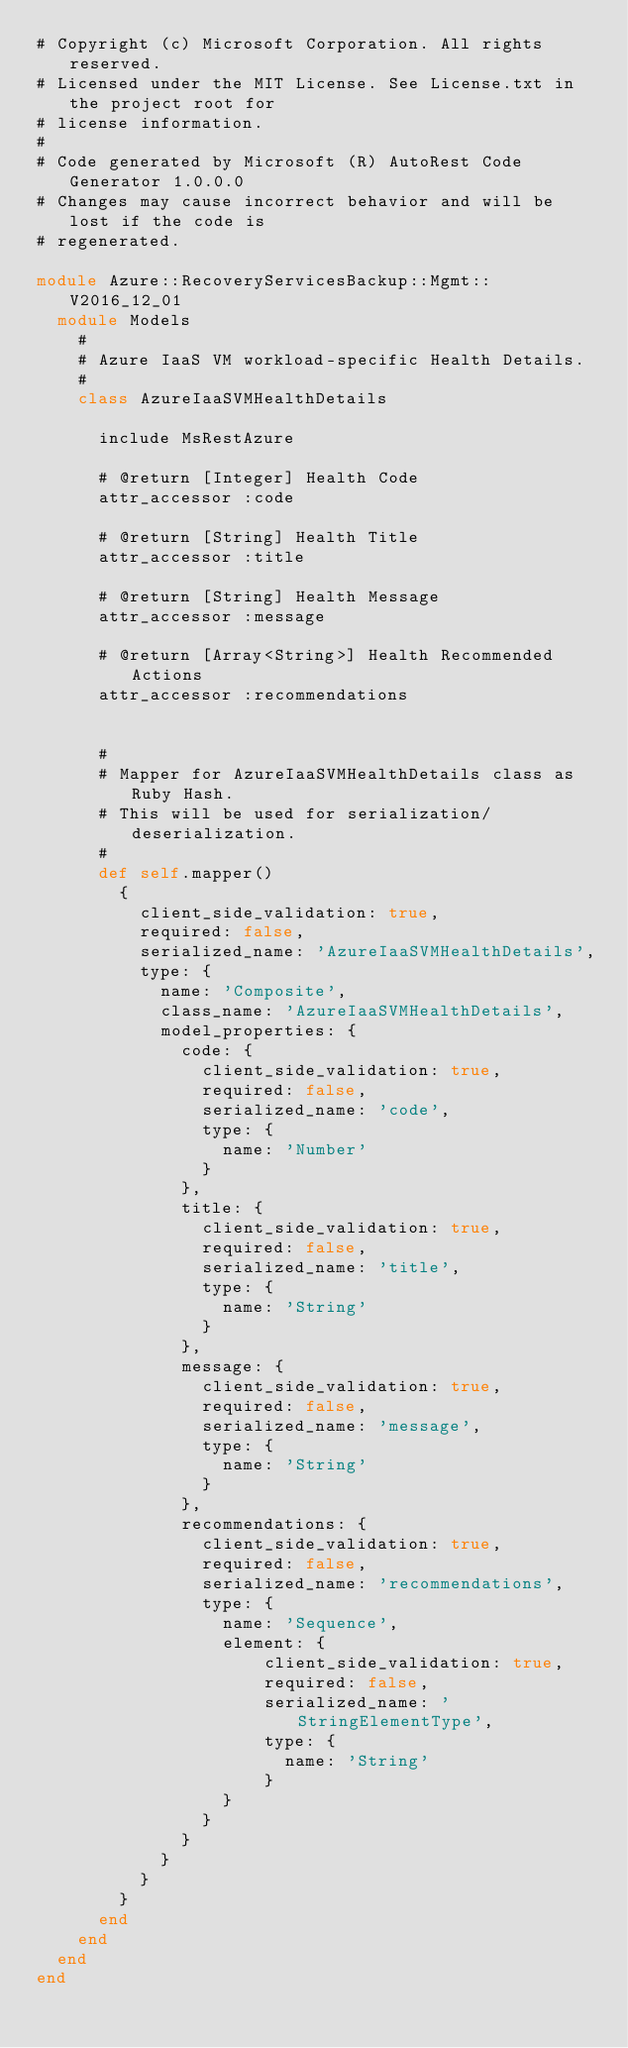<code> <loc_0><loc_0><loc_500><loc_500><_Ruby_># Copyright (c) Microsoft Corporation. All rights reserved.
# Licensed under the MIT License. See License.txt in the project root for
# license information.
#
# Code generated by Microsoft (R) AutoRest Code Generator 1.0.0.0
# Changes may cause incorrect behavior and will be lost if the code is
# regenerated.

module Azure::RecoveryServicesBackup::Mgmt::V2016_12_01
  module Models
    #
    # Azure IaaS VM workload-specific Health Details.
    #
    class AzureIaaSVMHealthDetails

      include MsRestAzure

      # @return [Integer] Health Code
      attr_accessor :code

      # @return [String] Health Title
      attr_accessor :title

      # @return [String] Health Message
      attr_accessor :message

      # @return [Array<String>] Health Recommended Actions
      attr_accessor :recommendations


      #
      # Mapper for AzureIaaSVMHealthDetails class as Ruby Hash.
      # This will be used for serialization/deserialization.
      #
      def self.mapper()
        {
          client_side_validation: true,
          required: false,
          serialized_name: 'AzureIaaSVMHealthDetails',
          type: {
            name: 'Composite',
            class_name: 'AzureIaaSVMHealthDetails',
            model_properties: {
              code: {
                client_side_validation: true,
                required: false,
                serialized_name: 'code',
                type: {
                  name: 'Number'
                }
              },
              title: {
                client_side_validation: true,
                required: false,
                serialized_name: 'title',
                type: {
                  name: 'String'
                }
              },
              message: {
                client_side_validation: true,
                required: false,
                serialized_name: 'message',
                type: {
                  name: 'String'
                }
              },
              recommendations: {
                client_side_validation: true,
                required: false,
                serialized_name: 'recommendations',
                type: {
                  name: 'Sequence',
                  element: {
                      client_side_validation: true,
                      required: false,
                      serialized_name: 'StringElementType',
                      type: {
                        name: 'String'
                      }
                  }
                }
              }
            }
          }
        }
      end
    end
  end
end
</code> 